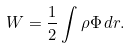Convert formula to latex. <formula><loc_0><loc_0><loc_500><loc_500>W = \frac { 1 } { 2 } \int \rho \Phi \, d { r } .</formula> 